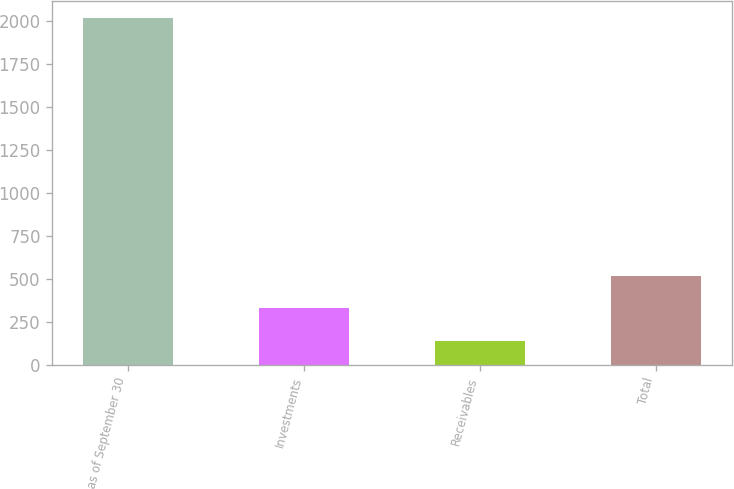<chart> <loc_0><loc_0><loc_500><loc_500><bar_chart><fcel>as of September 30<fcel>Investments<fcel>Receivables<fcel>Total<nl><fcel>2018<fcel>327.89<fcel>140.1<fcel>515.68<nl></chart> 